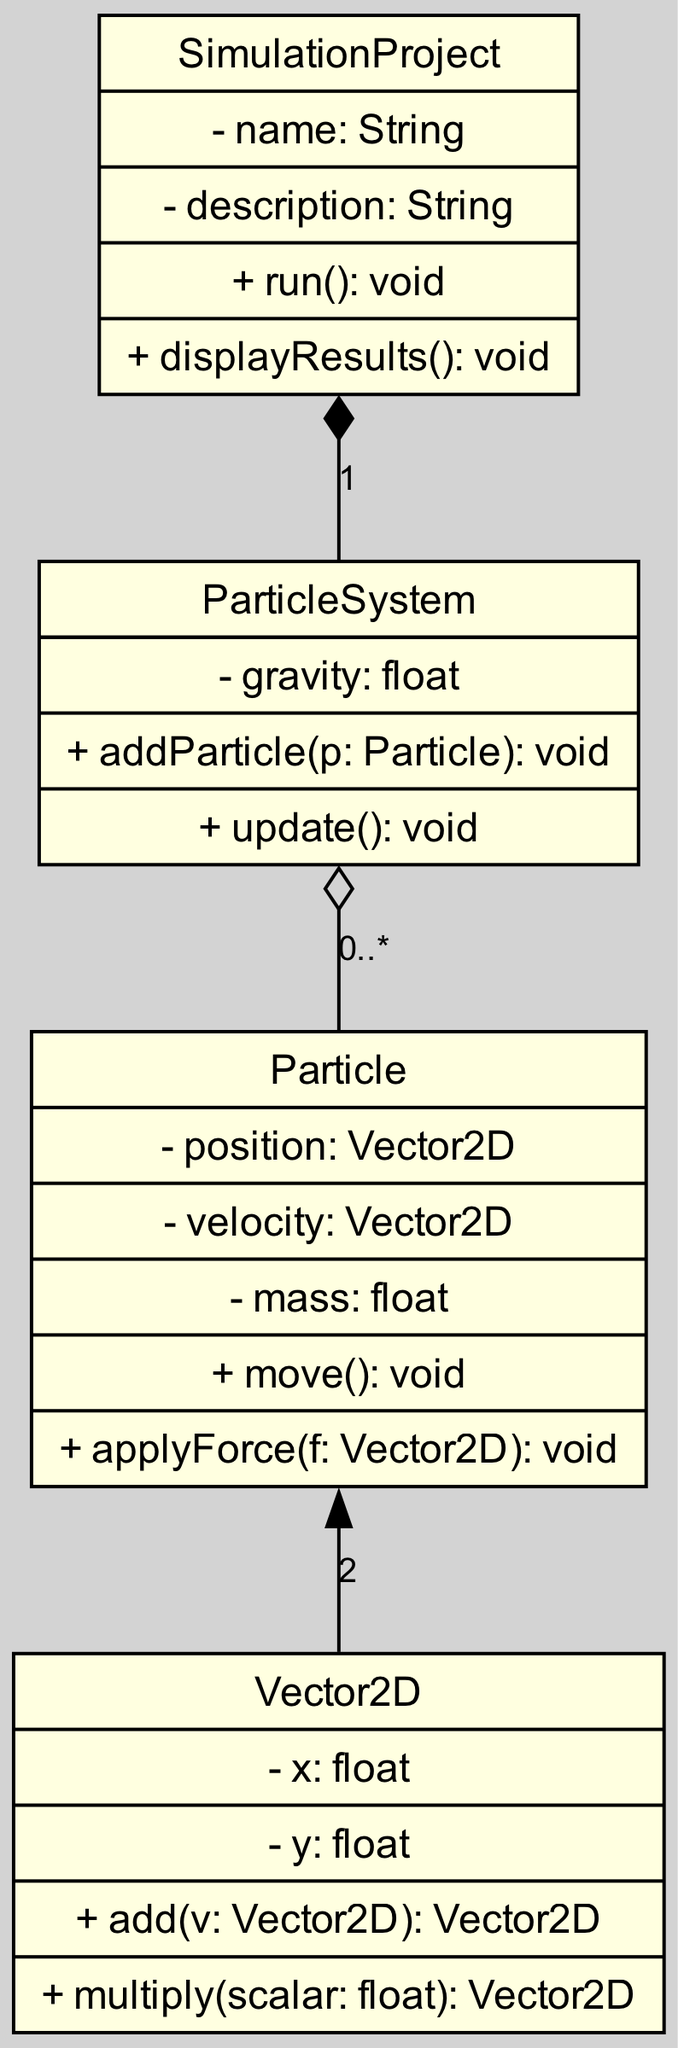What are the attributes of the Particle class? The Particle class has three attributes listed: position, velocity, and mass. These attributes are defined within the class box in the diagram.
Answer: position, velocity, mass How many classes are in the UML diagram? By counting the nodes representing classes in the diagram, we find four classes: SimulationProject, ParticleSystem, Particle, and Vector2D.
Answer: 4 What type of relationship exists between SimulationProject and ParticleSystem? The relationship between SimulationProject and ParticleSystem is labeled as composition in the diagram, indicated by a diamond on the ParticleSystem end and having the label "1".
Answer: composition How many particles can a ParticleSystem contain? The ParticleSystem can contain zero or more particles, as denoted by the "0..*" label in the aggregation relationship to the Particle class.
Answer: 0..* Which class directly uses the Vector2D class? The Particle class directly uses the Vector2D class, as indicated by the association relationship represented with a plain line connecting Particle and Vector2D.
Answer: Particle What is the return type of the run method in the SimulationProject class? The run method in the SimulationProject class does not return any value, as noted by the return type "void" present next to the method signature in the diagram.
Answer: void How many methods does the Particle class have? The Particle class has two methods listed: move and applyForce. Counting these methods gives us a total of two methods defined in that class.
Answer: 2 What is the label on the relationship from ParticleSystem to Particle? The label on the relationship from ParticleSystem to Particle indicates the cardinality of the aggregation relationship, which is shown as "0..*". This means the ParticleSystem can have zero to many Particle instances.
Answer: 0..* Which class contains a method for displaying results? The SimulationProject class contains the method displayResults. This is referenced within the methods section of that class in the diagram.
Answer: SimulationProject 